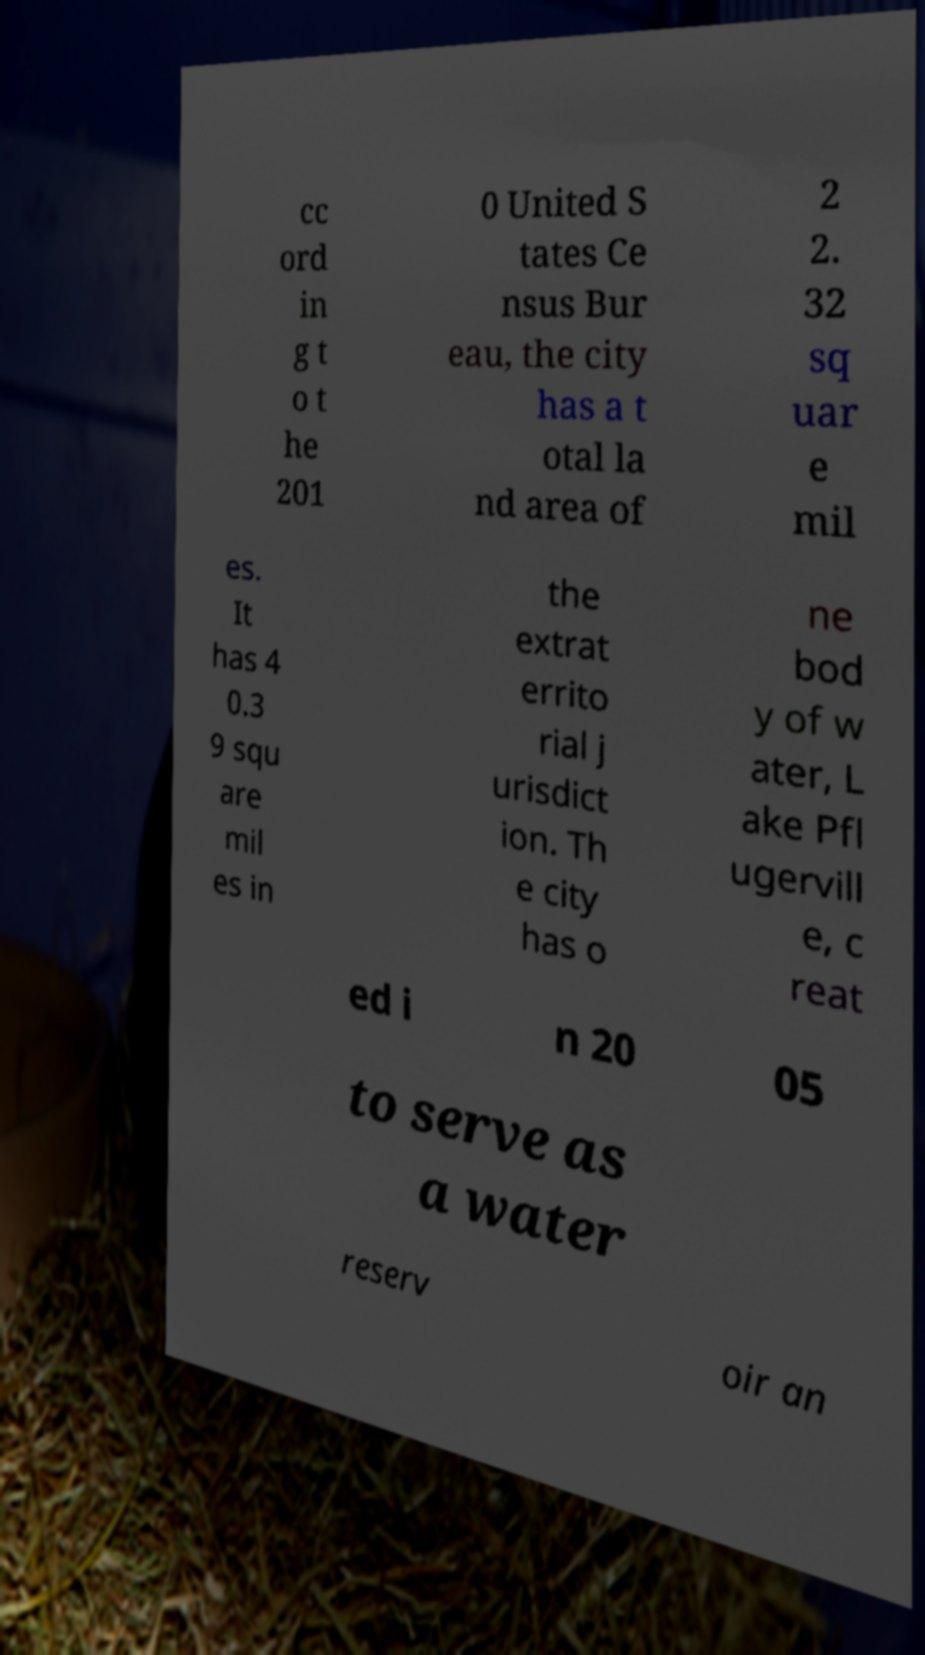I need the written content from this picture converted into text. Can you do that? cc ord in g t o t he 201 0 United S tates Ce nsus Bur eau, the city has a t otal la nd area of 2 2. 32 sq uar e mil es. It has 4 0.3 9 squ are mil es in the extrat errito rial j urisdict ion. Th e city has o ne bod y of w ater, L ake Pfl ugervill e, c reat ed i n 20 05 to serve as a water reserv oir an 